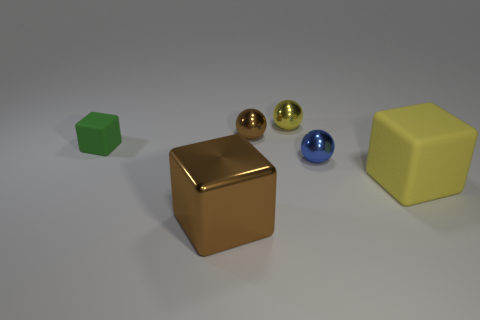The tiny block has what color?
Offer a very short reply. Green. Does the yellow object that is behind the yellow cube have the same shape as the tiny blue metallic object?
Your answer should be very brief. Yes. Are there fewer yellow shiny objects on the right side of the yellow rubber thing than cubes right of the small yellow metallic thing?
Provide a succinct answer. Yes. What material is the object in front of the big yellow block?
Keep it short and to the point. Metal. The sphere that is the same color as the big metal block is what size?
Give a very brief answer. Small. Are there any cylinders of the same size as the green thing?
Your answer should be very brief. No. Is the shape of the tiny blue thing the same as the yellow thing that is behind the small blue ball?
Your answer should be compact. Yes. There is a matte object on the right side of the big metallic cube; is it the same size as the sphere that is right of the tiny yellow thing?
Provide a succinct answer. No. How many other objects are there of the same shape as the tiny blue thing?
Give a very brief answer. 2. The big cube that is in front of the rubber thing that is in front of the green rubber cube is made of what material?
Offer a terse response. Metal. 